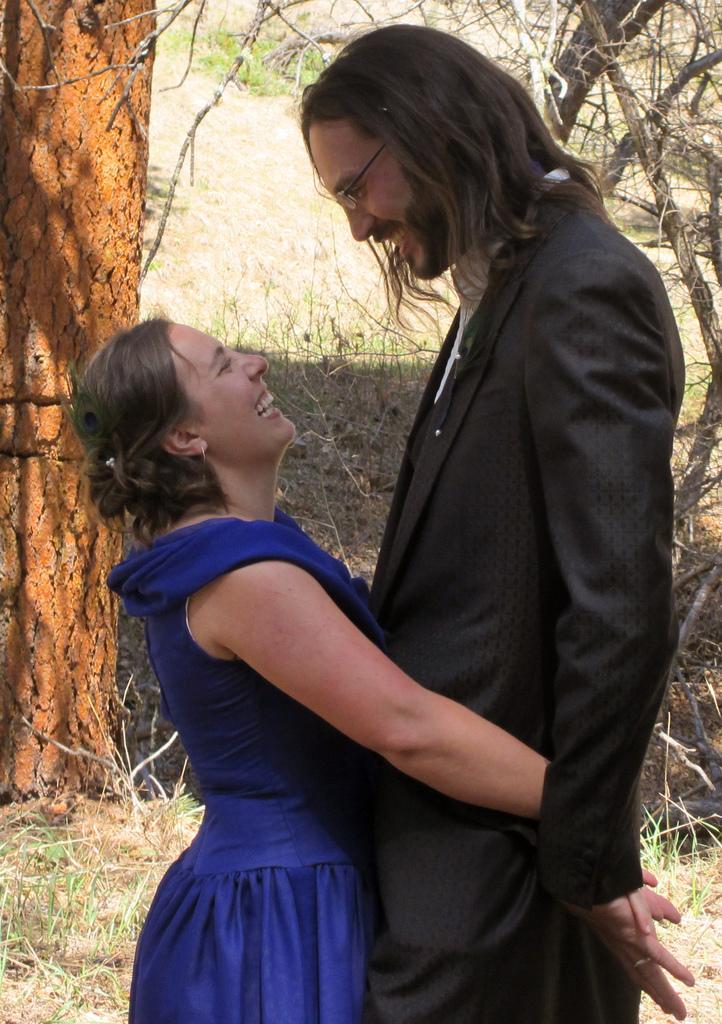Please provide a concise description of this image. In this picture I can see couple of them standing and I can see a woman holding man with her hands and I can see trees in the back and grass on the ground. 